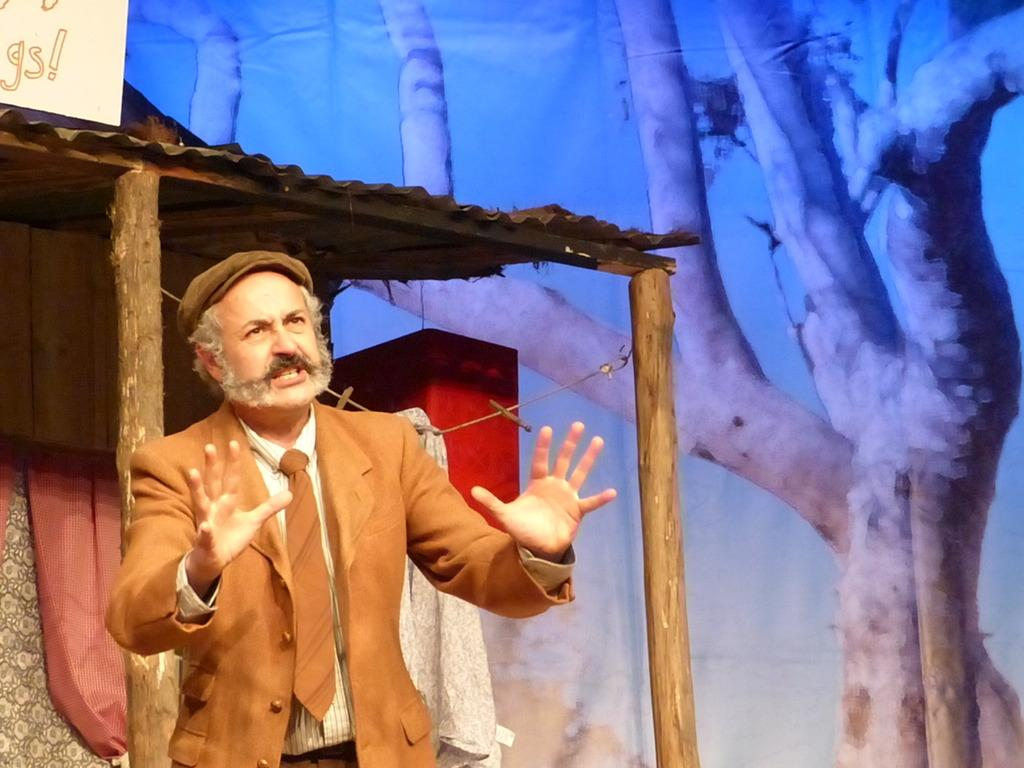What is the man doing on the left side of the image? The man is standing on the left side of the image and talking. What is the man wearing in the image? The man is wearing a suit in the image. What can be seen in the background of the image? There is a shed and a tree in the background of the image. What type of coil is the man holding in the image? There is no coil present in the image; the man is simply standing and talking. 